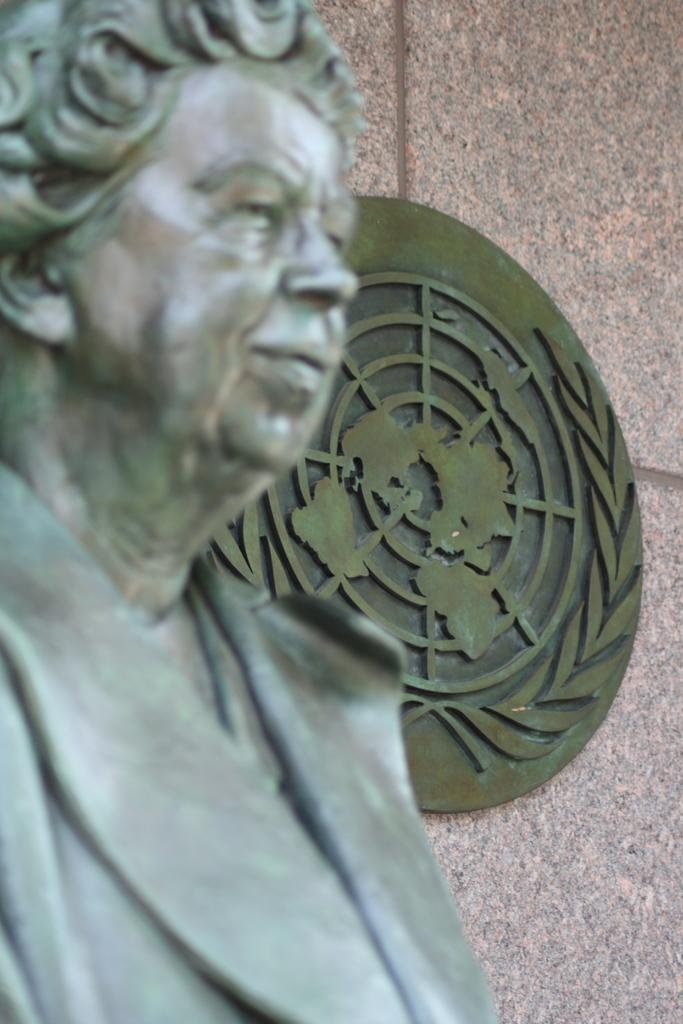What is the main subject in the foreground of the image? There is a statue in the foreground of the image. Can you describe the object on the wall in the background of the image? There is a round object on the wall in the background of the image. What type of powder is being used to make popcorn in the image? There is no popcorn or powder present in the image. 